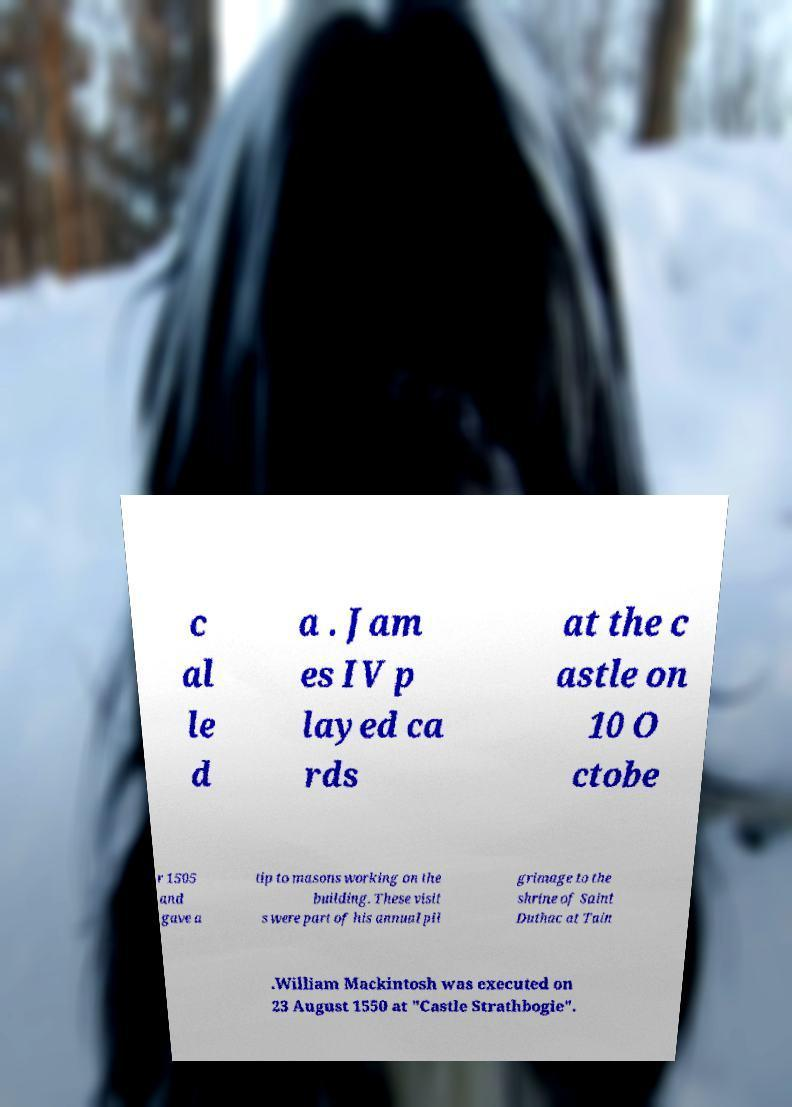There's text embedded in this image that I need extracted. Can you transcribe it verbatim? c al le d a . Jam es IV p layed ca rds at the c astle on 10 O ctobe r 1505 and gave a tip to masons working on the building. These visit s were part of his annual pil grimage to the shrine of Saint Duthac at Tain .William Mackintosh was executed on 23 August 1550 at "Castle Strathbogie". 